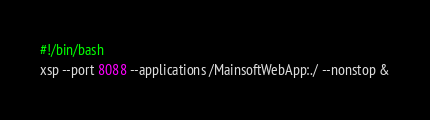<code> <loc_0><loc_0><loc_500><loc_500><_Bash_>#!/bin/bash
xsp --port 8088 --applications /MainsoftWebApp:./ --nonstop &</code> 